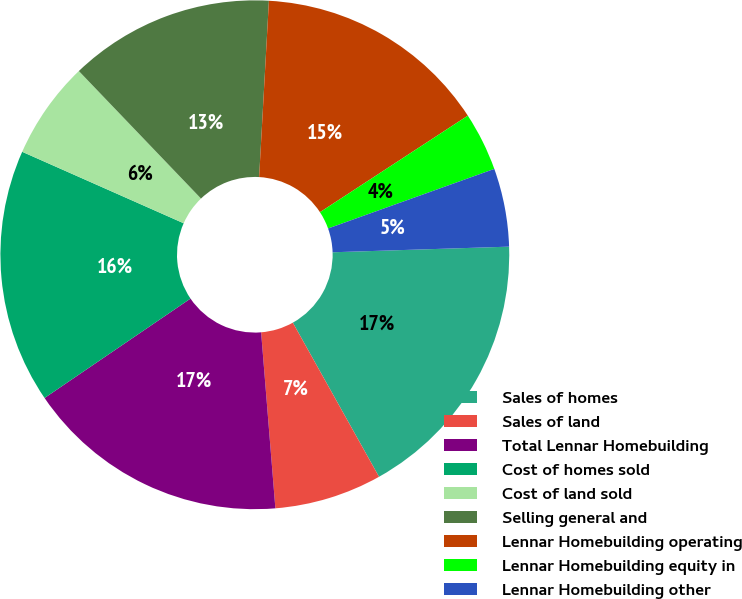Convert chart. <chart><loc_0><loc_0><loc_500><loc_500><pie_chart><fcel>Sales of homes<fcel>Sales of land<fcel>Total Lennar Homebuilding<fcel>Cost of homes sold<fcel>Cost of land sold<fcel>Selling general and<fcel>Lennar Homebuilding operating<fcel>Lennar Homebuilding equity in<fcel>Lennar Homebuilding other<nl><fcel>17.39%<fcel>6.83%<fcel>16.77%<fcel>16.15%<fcel>6.21%<fcel>13.04%<fcel>14.91%<fcel>3.73%<fcel>4.97%<nl></chart> 